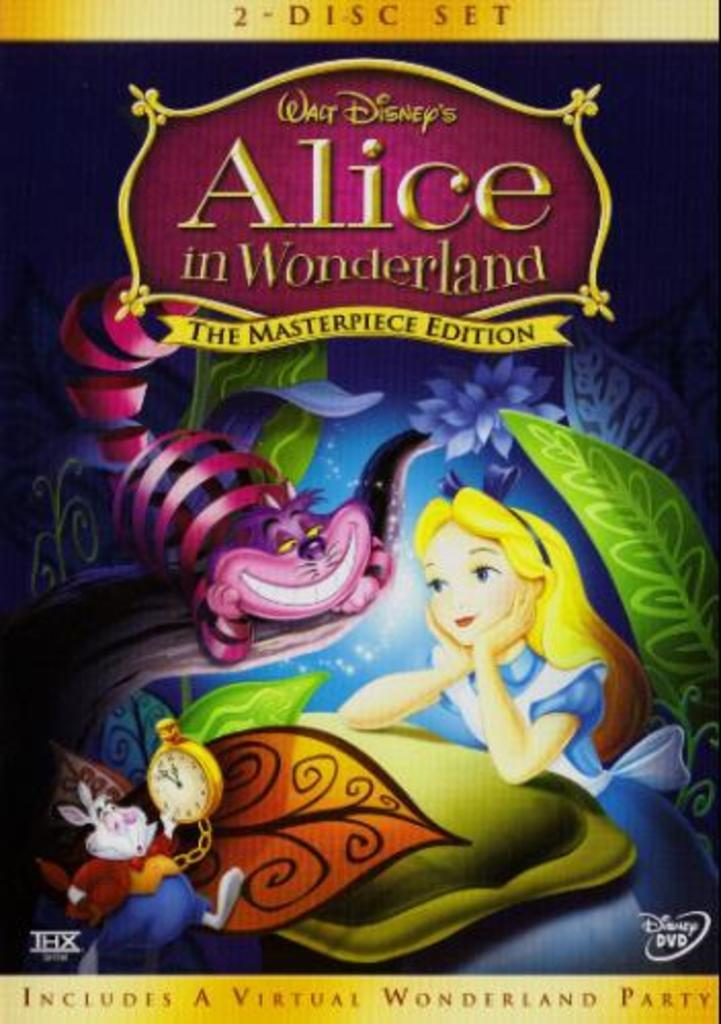<image>
Write a terse but informative summary of the picture. A 2 disc set of Alice in Wonderland is a masterpiece edition. 